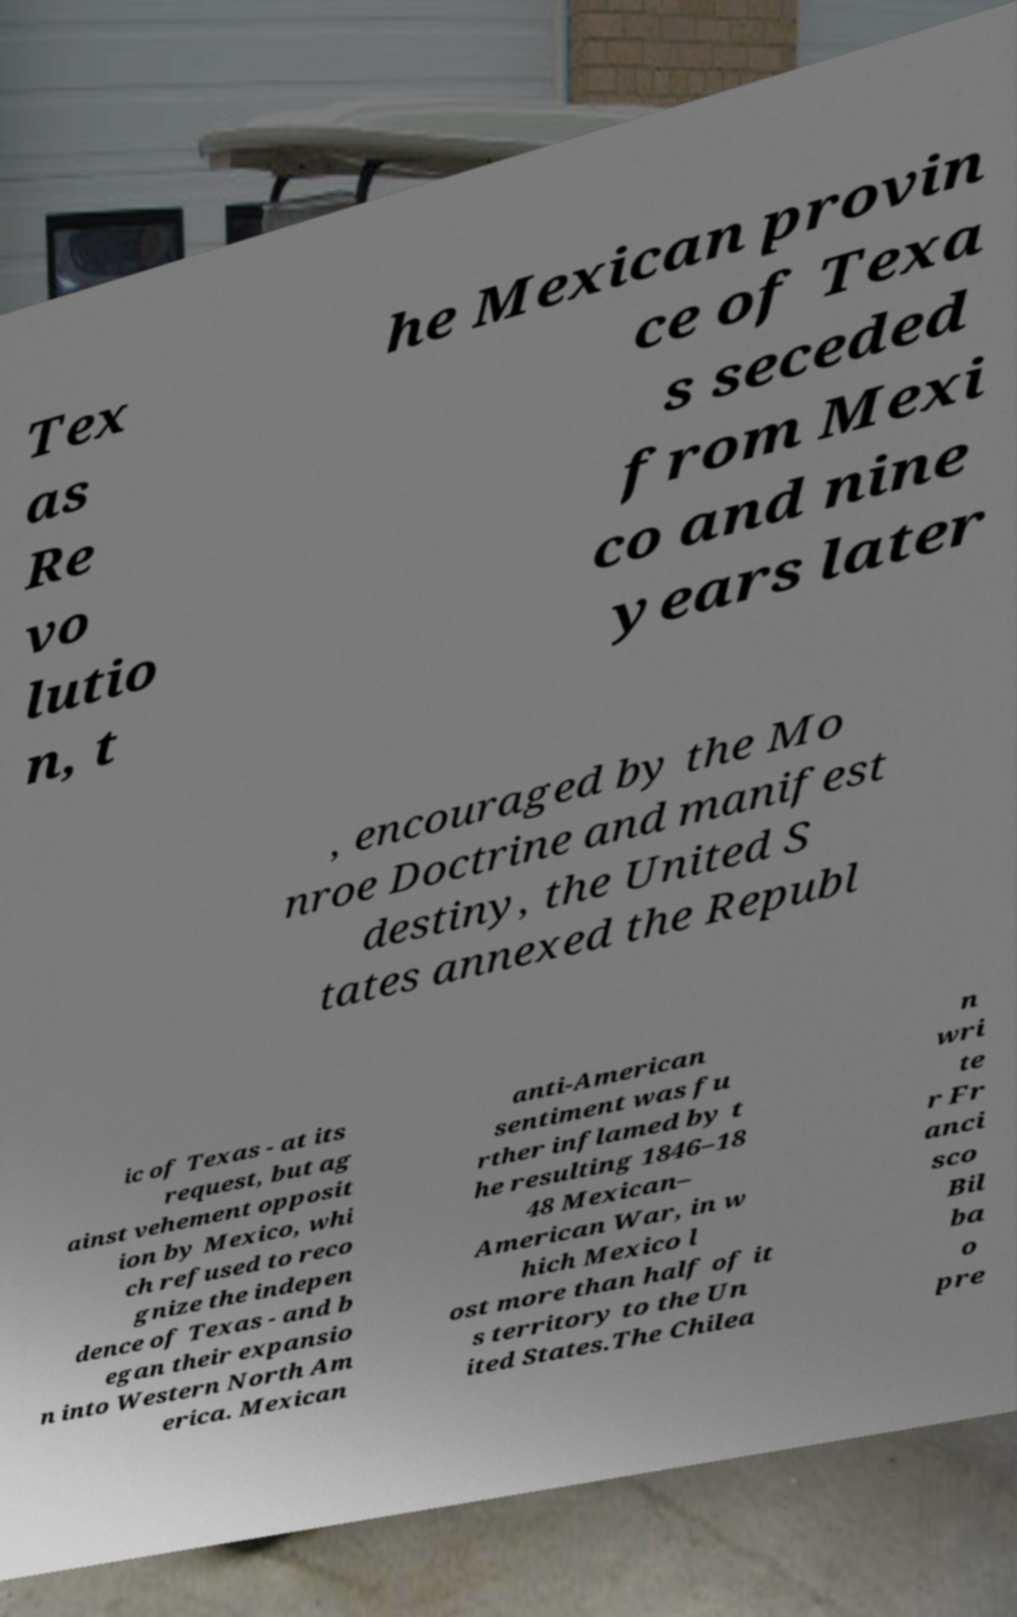There's text embedded in this image that I need extracted. Can you transcribe it verbatim? Tex as Re vo lutio n, t he Mexican provin ce of Texa s seceded from Mexi co and nine years later , encouraged by the Mo nroe Doctrine and manifest destiny, the United S tates annexed the Republ ic of Texas - at its request, but ag ainst vehement opposit ion by Mexico, whi ch refused to reco gnize the indepen dence of Texas - and b egan their expansio n into Western North Am erica. Mexican anti-American sentiment was fu rther inflamed by t he resulting 1846–18 48 Mexican– American War, in w hich Mexico l ost more than half of it s territory to the Un ited States.The Chilea n wri te r Fr anci sco Bil ba o pre 